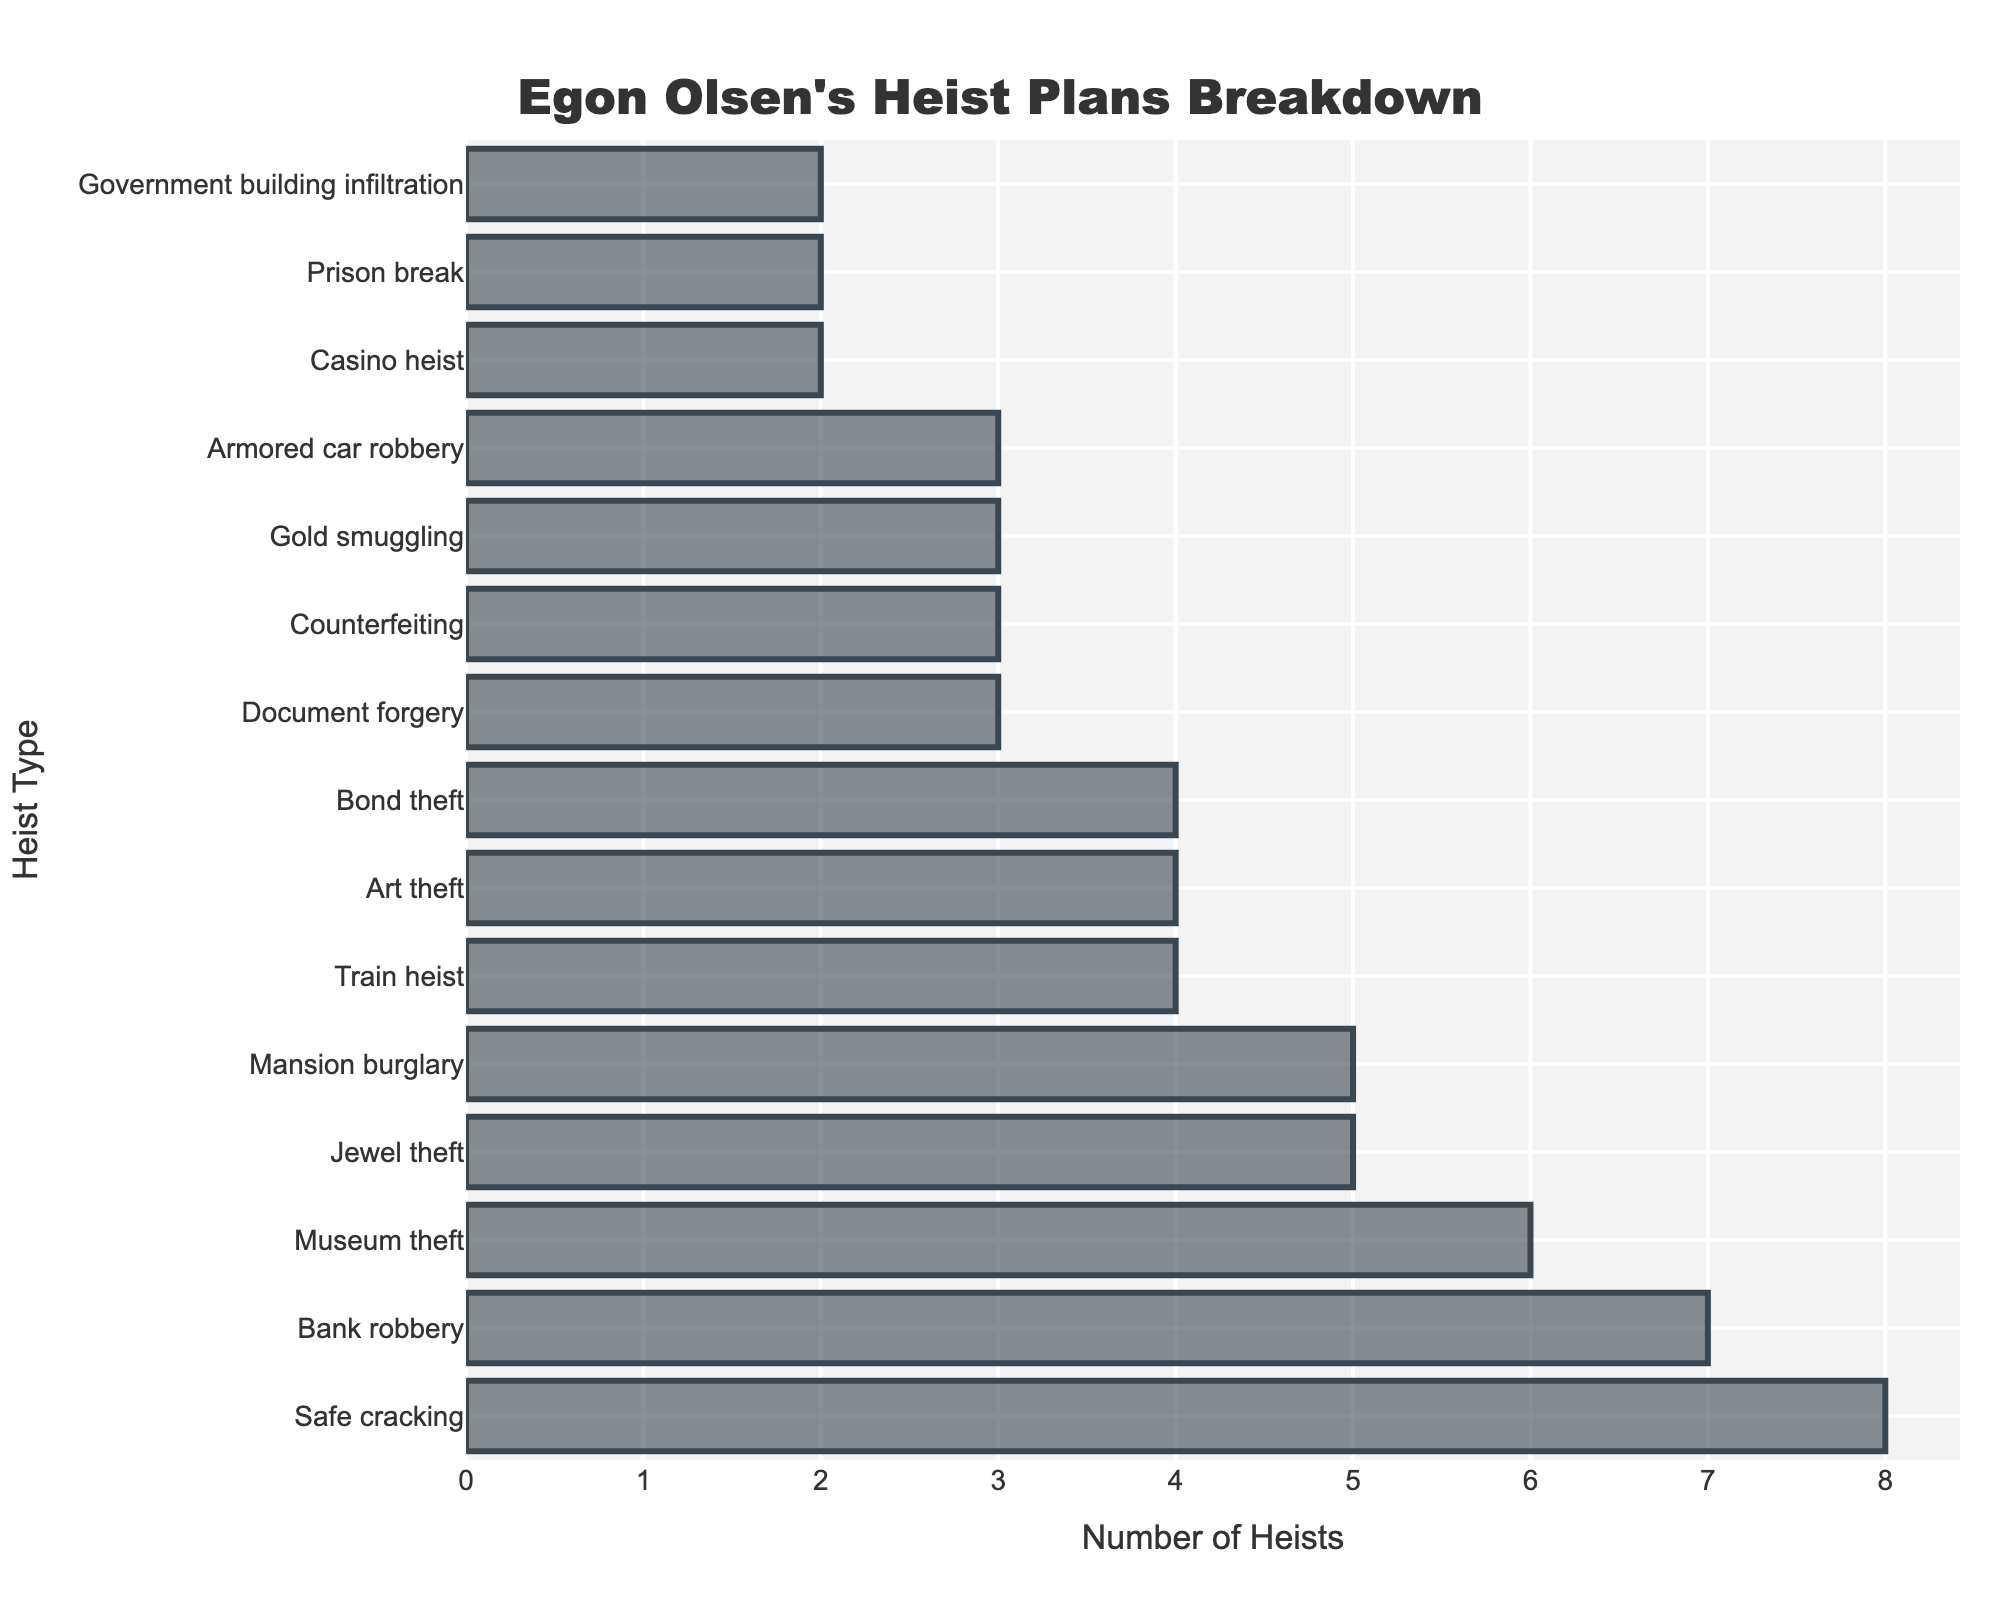Which heist type did Egon Olsen plan the most? By looking at the bar lengths, "Safe cracking" has the longest bar, indicating it is the most frequently planned heist type by Egon Olsen.
Answer: Safe cracking How many more bank robberies than casino heists did Egon Olsen plan? From the data, the number of bank robberies is 7 and casino heists is 2. Subtracting these gives: 7 - 2 = 5.
Answer: 5 What are the two least frequent heist types in Egon Olsen's plans? The bars corresponding to "Casino heist" and "Prison break" are the shortest, both having a count of 2.
Answer: Casino heist, Prison break How many heist plans involve theft of valuable items (jewel, art, gold)? Summing up the counts for Jewel theft (5), Art theft (4), and Gold smuggling (3) gives: 5 + 4 + 3 = 12.
Answer: 12 Which planned heist types have an equal number of occurrences? Comparing the lengths of the bars, "Document forgery", "Counterfeiting", "Gold smuggling", and "Armored car robbery" each appear 3 times. Similarly, "Train heist", "Art theft", and "Bond theft" each appear 4 times.
Answer: Document forgery, Counterfeiting, Gold smuggling, Armored car robbery; Train heist, Art theft, Bond theft What is the total count of heist plans listed in the figure? Summing up counts for all heist types in the chart: 7 + 5 + 3 + 4 + 6 + 8 + 3 + 4 + 2 + 5 + 3 + 4 + 2 + 3 + 2 = 61.
Answer: 61 How many more times did Egon plan mansion burglaries compared to government building infiltrations? Mansion burglary count is 5 and government building infiltration is 2. The difference is: 5 - 2 = 3.
Answer: 3 Which heist types have counts greater than the median count in the figure? The counts are {2, 2, 2, 3, 3, 3, 3, 4, 4, 4, 5, 5, 6, 7, 8}. The median is the middle value, which is 4. Types with counts greater than 4 are "Bank robbery" (7), "Museum theft" (6), "Safe cracking" (8), and "Mansion burglary" (5), "Jewel theft" (5).
Answer: Bank robbery, Museum theft, Safe cracking, Mansion burglary, Jewel theft 